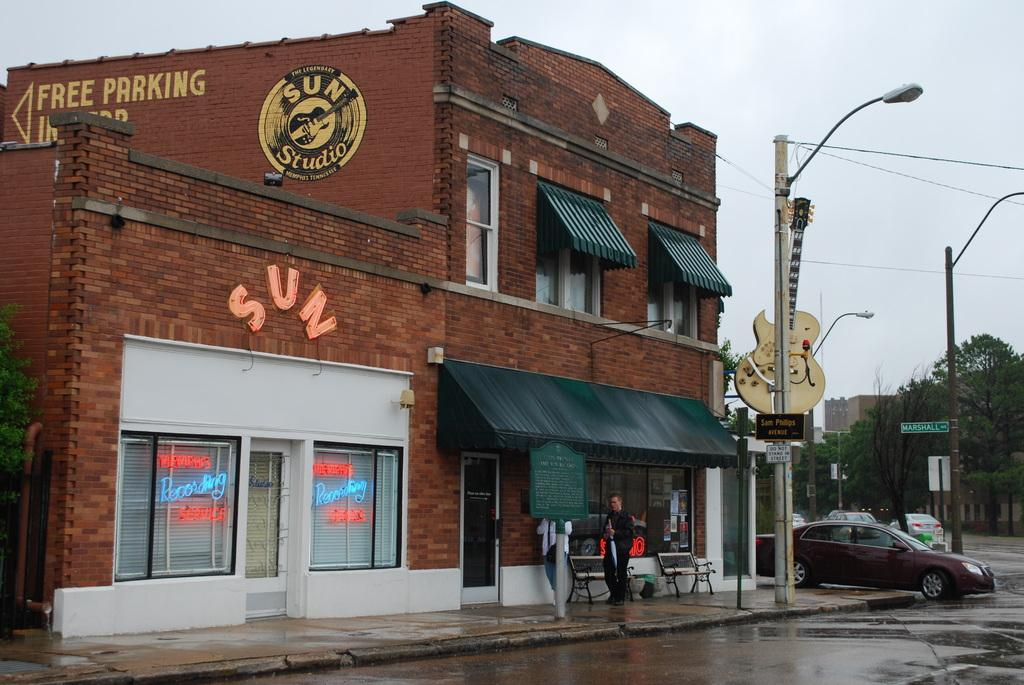<image>
Create a compact narrative representing the image presented. A brick building has a round Sun Studio sign on the side. 